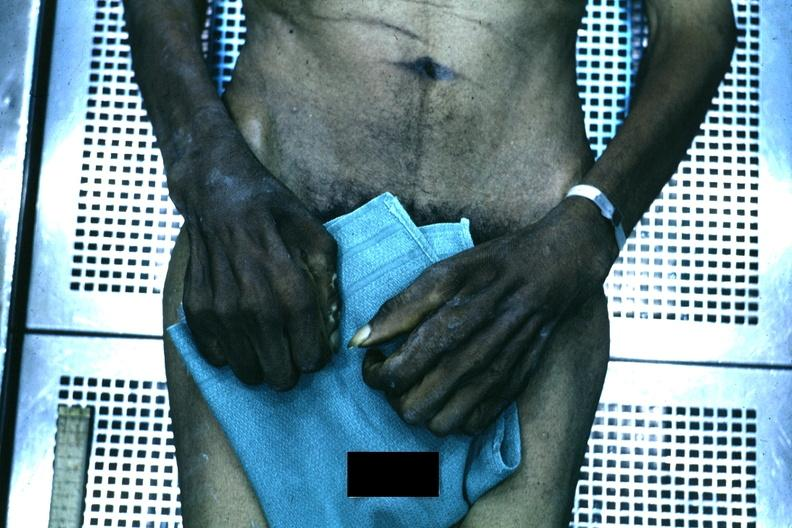why is good example of muscle atrophy said to be?
Answer the question using a single word or phrase. Due syringomyelia 